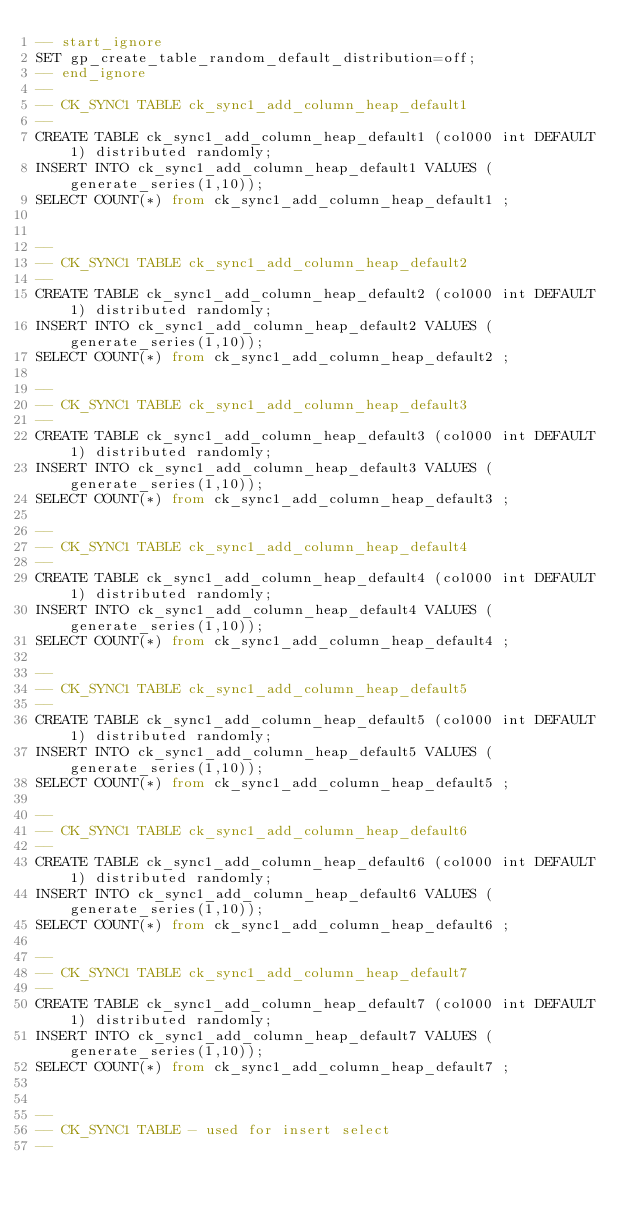Convert code to text. <code><loc_0><loc_0><loc_500><loc_500><_SQL_>-- start_ignore
SET gp_create_table_random_default_distribution=off;
-- end_ignore
--
-- CK_SYNC1 TABLE ck_sync1_add_column_heap_default1
--
CREATE TABLE ck_sync1_add_column_heap_default1 (col000 int DEFAULT 1) distributed randomly;
INSERT INTO ck_sync1_add_column_heap_default1 VALUES (generate_series(1,10));
SELECT COUNT(*) from ck_sync1_add_column_heap_default1 ;


--
-- CK_SYNC1 TABLE ck_sync1_add_column_heap_default2
--
CREATE TABLE ck_sync1_add_column_heap_default2 (col000 int DEFAULT 1) distributed randomly;
INSERT INTO ck_sync1_add_column_heap_default2 VALUES (generate_series(1,10));
SELECT COUNT(*) from ck_sync1_add_column_heap_default2 ;

--
-- CK_SYNC1 TABLE ck_sync1_add_column_heap_default3
--
CREATE TABLE ck_sync1_add_column_heap_default3 (col000 int DEFAULT 1) distributed randomly;
INSERT INTO ck_sync1_add_column_heap_default3 VALUES (generate_series(1,10));
SELECT COUNT(*) from ck_sync1_add_column_heap_default3 ;

--
-- CK_SYNC1 TABLE ck_sync1_add_column_heap_default4
--
CREATE TABLE ck_sync1_add_column_heap_default4 (col000 int DEFAULT 1) distributed randomly;
INSERT INTO ck_sync1_add_column_heap_default4 VALUES (generate_series(1,10));
SELECT COUNT(*) from ck_sync1_add_column_heap_default4 ;

--
-- CK_SYNC1 TABLE ck_sync1_add_column_heap_default5
--
CREATE TABLE ck_sync1_add_column_heap_default5 (col000 int DEFAULT 1) distributed randomly;
INSERT INTO ck_sync1_add_column_heap_default5 VALUES (generate_series(1,10));
SELECT COUNT(*) from ck_sync1_add_column_heap_default5 ;

--
-- CK_SYNC1 TABLE ck_sync1_add_column_heap_default6
--
CREATE TABLE ck_sync1_add_column_heap_default6 (col000 int DEFAULT 1) distributed randomly;
INSERT INTO ck_sync1_add_column_heap_default6 VALUES (generate_series(1,10));
SELECT COUNT(*) from ck_sync1_add_column_heap_default6 ;

--
-- CK_SYNC1 TABLE ck_sync1_add_column_heap_default7
--
CREATE TABLE ck_sync1_add_column_heap_default7 (col000 int DEFAULT 1) distributed randomly;
INSERT INTO ck_sync1_add_column_heap_default7 VALUES (generate_series(1,10));
SELECT COUNT(*) from ck_sync1_add_column_heap_default7 ;


--
-- CK_SYNC1 TABLE - used for insert select
--
</code> 